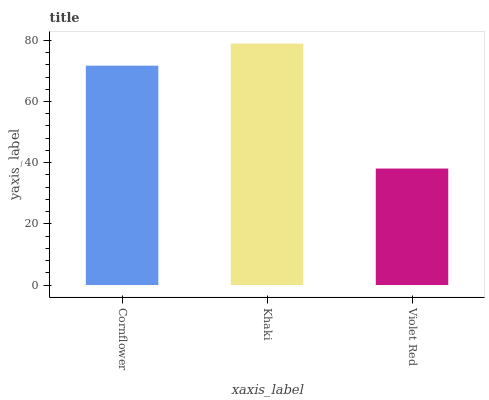Is Violet Red the minimum?
Answer yes or no. Yes. Is Khaki the maximum?
Answer yes or no. Yes. Is Khaki the minimum?
Answer yes or no. No. Is Violet Red the maximum?
Answer yes or no. No. Is Khaki greater than Violet Red?
Answer yes or no. Yes. Is Violet Red less than Khaki?
Answer yes or no. Yes. Is Violet Red greater than Khaki?
Answer yes or no. No. Is Khaki less than Violet Red?
Answer yes or no. No. Is Cornflower the high median?
Answer yes or no. Yes. Is Cornflower the low median?
Answer yes or no. Yes. Is Violet Red the high median?
Answer yes or no. No. Is Khaki the low median?
Answer yes or no. No. 